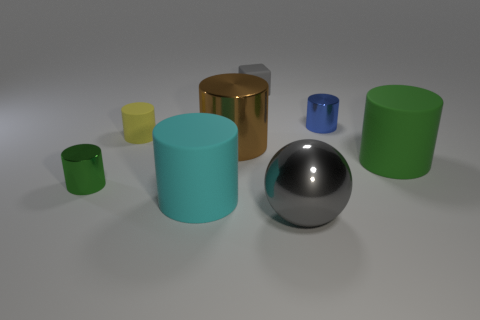Subtract all green cylinders. How many cylinders are left? 4 Subtract all yellow blocks. How many green cylinders are left? 2 Add 2 small rubber things. How many objects exist? 10 Subtract all green cylinders. How many cylinders are left? 4 Subtract all balls. How many objects are left? 7 Subtract all red cylinders. Subtract all red spheres. How many cylinders are left? 6 Add 6 gray shiny things. How many gray shiny things are left? 7 Add 2 brown shiny objects. How many brown shiny objects exist? 3 Subtract 0 cyan spheres. How many objects are left? 8 Subtract all large cyan cylinders. Subtract all small green metallic cylinders. How many objects are left? 6 